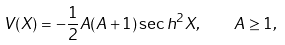Convert formula to latex. <formula><loc_0><loc_0><loc_500><loc_500>V ( X ) = - \frac { 1 } { 2 } A ( A + 1 ) \sec h ^ { 2 } X , \quad A \geq 1 ,</formula> 